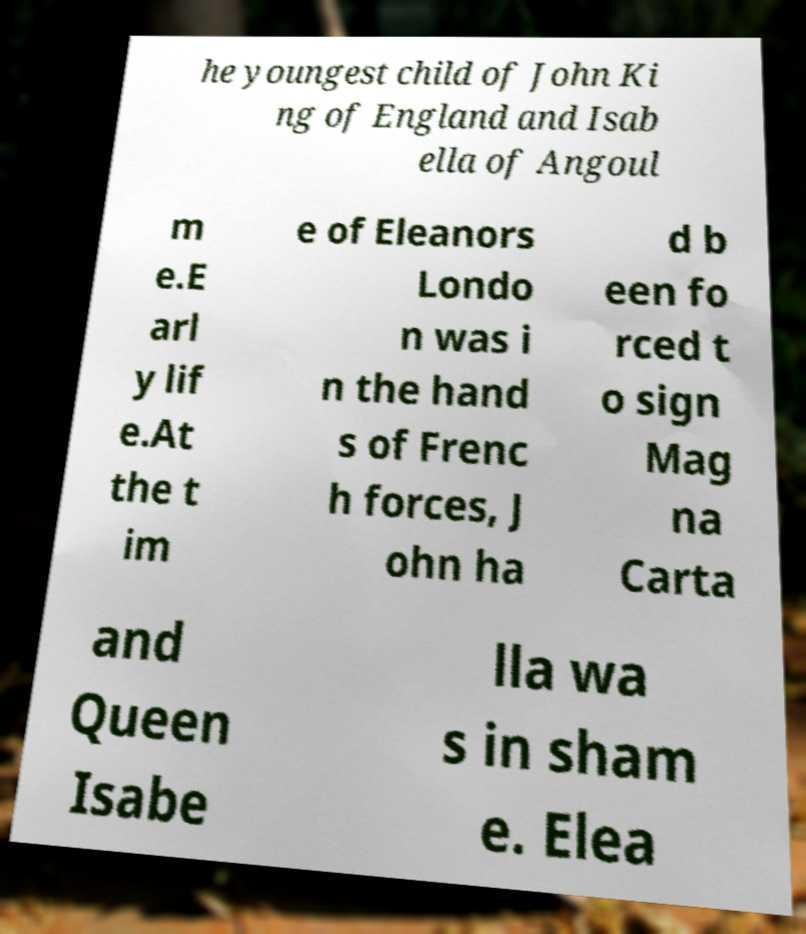I need the written content from this picture converted into text. Can you do that? he youngest child of John Ki ng of England and Isab ella of Angoul m e.E arl y lif e.At the t im e of Eleanors Londo n was i n the hand s of Frenc h forces, J ohn ha d b een fo rced t o sign Mag na Carta and Queen Isabe lla wa s in sham e. Elea 